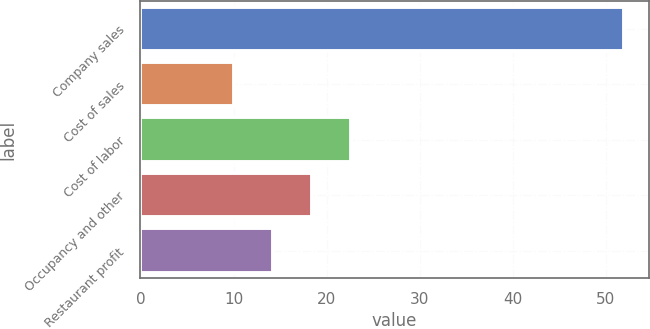<chart> <loc_0><loc_0><loc_500><loc_500><bar_chart><fcel>Company sales<fcel>Cost of sales<fcel>Cost of labor<fcel>Occupancy and other<fcel>Restaurant profit<nl><fcel>52<fcel>10<fcel>22.6<fcel>18.4<fcel>14.2<nl></chart> 